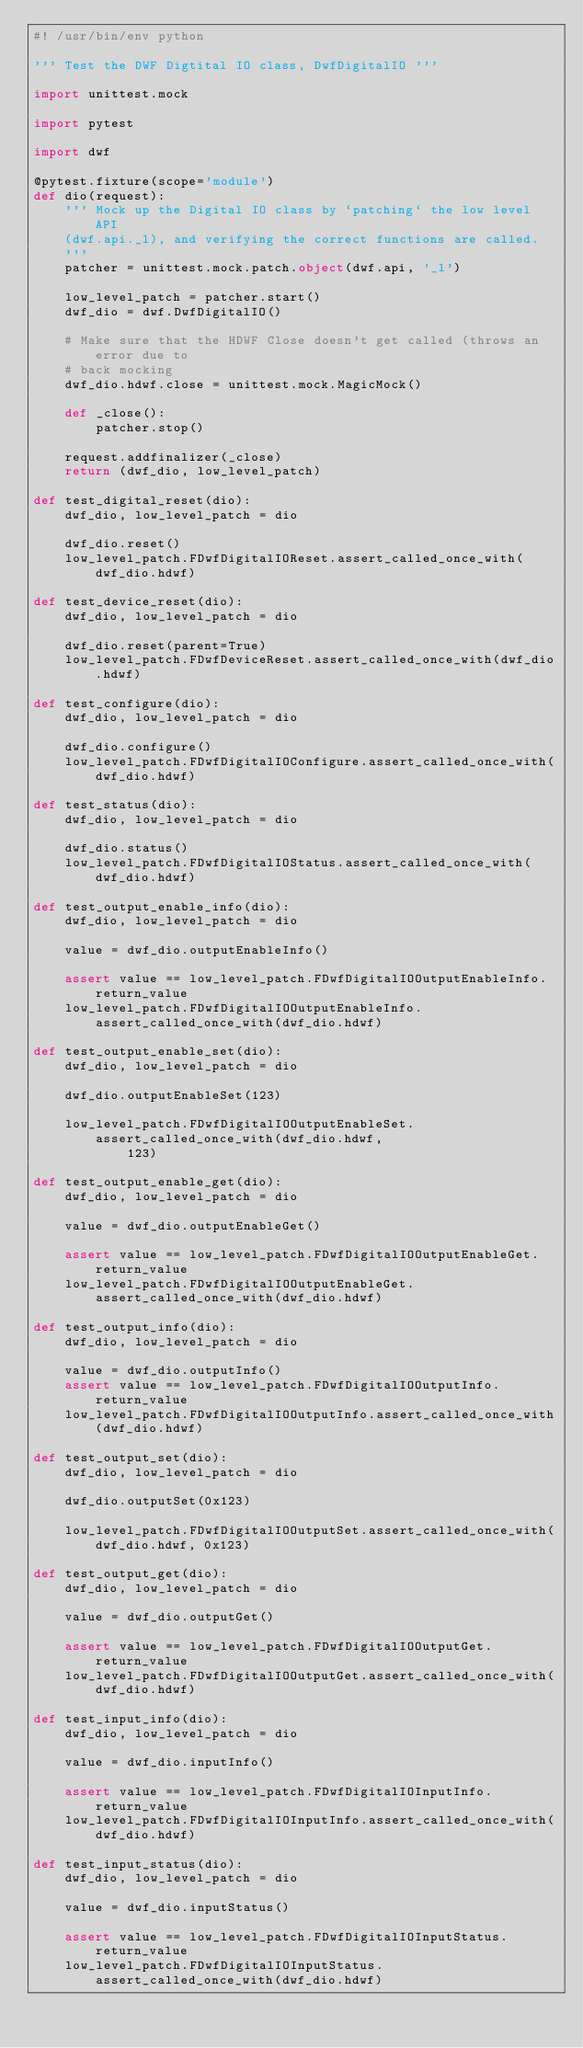Convert code to text. <code><loc_0><loc_0><loc_500><loc_500><_Python_>#! /usr/bin/env python

''' Test the DWF Digtital IO class, DwfDigitalIO '''

import unittest.mock

import pytest

import dwf

@pytest.fixture(scope='module')
def dio(request):
    ''' Mock up the Digital IO class by `patching` the low level API
    (dwf.api._l), and verifying the correct functions are called.
    '''
    patcher = unittest.mock.patch.object(dwf.api, '_l')

    low_level_patch = patcher.start()
    dwf_dio = dwf.DwfDigitalIO()

    # Make sure that the HDWF Close doesn't get called (throws an error due to
    # back mocking
    dwf_dio.hdwf.close = unittest.mock.MagicMock()

    def _close():
        patcher.stop()

    request.addfinalizer(_close)
    return (dwf_dio, low_level_patch)

def test_digital_reset(dio):
    dwf_dio, low_level_patch = dio

    dwf_dio.reset()
    low_level_patch.FDwfDigitalIOReset.assert_called_once_with(dwf_dio.hdwf)

def test_device_reset(dio):
    dwf_dio, low_level_patch = dio

    dwf_dio.reset(parent=True)
    low_level_patch.FDwfDeviceReset.assert_called_once_with(dwf_dio.hdwf)

def test_configure(dio):
    dwf_dio, low_level_patch = dio

    dwf_dio.configure()
    low_level_patch.FDwfDigitalIOConfigure.assert_called_once_with(dwf_dio.hdwf)

def test_status(dio):
    dwf_dio, low_level_patch = dio

    dwf_dio.status()
    low_level_patch.FDwfDigitalIOStatus.assert_called_once_with(dwf_dio.hdwf)

def test_output_enable_info(dio):
    dwf_dio, low_level_patch = dio

    value = dwf_dio.outputEnableInfo()

    assert value == low_level_patch.FDwfDigitalIOOutputEnableInfo.return_value
    low_level_patch.FDwfDigitalIOOutputEnableInfo.assert_called_once_with(dwf_dio.hdwf)

def test_output_enable_set(dio):
    dwf_dio, low_level_patch = dio

    dwf_dio.outputEnableSet(123)

    low_level_patch.FDwfDigitalIOOutputEnableSet.assert_called_once_with(dwf_dio.hdwf,
            123)

def test_output_enable_get(dio):
    dwf_dio, low_level_patch = dio

    value = dwf_dio.outputEnableGet()

    assert value == low_level_patch.FDwfDigitalIOOutputEnableGet.return_value
    low_level_patch.FDwfDigitalIOOutputEnableGet.assert_called_once_with(dwf_dio.hdwf)

def test_output_info(dio):
    dwf_dio, low_level_patch = dio

    value = dwf_dio.outputInfo()
    assert value == low_level_patch.FDwfDigitalIOOutputInfo.return_value
    low_level_patch.FDwfDigitalIOOutputInfo.assert_called_once_with(dwf_dio.hdwf)

def test_output_set(dio):
    dwf_dio, low_level_patch = dio

    dwf_dio.outputSet(0x123)

    low_level_patch.FDwfDigitalIOOutputSet.assert_called_once_with(dwf_dio.hdwf, 0x123)

def test_output_get(dio):
    dwf_dio, low_level_patch = dio

    value = dwf_dio.outputGet()

    assert value == low_level_patch.FDwfDigitalIOOutputGet.return_value
    low_level_patch.FDwfDigitalIOOutputGet.assert_called_once_with(dwf_dio.hdwf)

def test_input_info(dio):
    dwf_dio, low_level_patch = dio

    value = dwf_dio.inputInfo()

    assert value == low_level_patch.FDwfDigitalIOInputInfo.return_value
    low_level_patch.FDwfDigitalIOInputInfo.assert_called_once_with(dwf_dio.hdwf)

def test_input_status(dio):
    dwf_dio, low_level_patch = dio

    value = dwf_dio.inputStatus()

    assert value == low_level_patch.FDwfDigitalIOInputStatus.return_value
    low_level_patch.FDwfDigitalIOInputStatus.assert_called_once_with(dwf_dio.hdwf)
</code> 